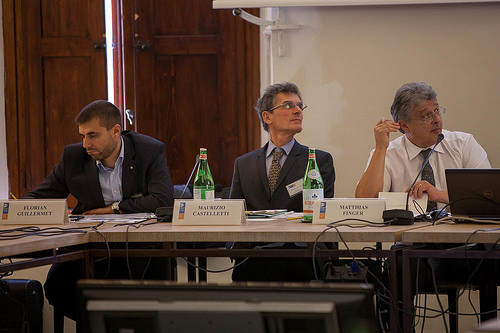<image>
Is the man in front of the table? No. The man is not in front of the table. The spatial positioning shows a different relationship between these objects. 